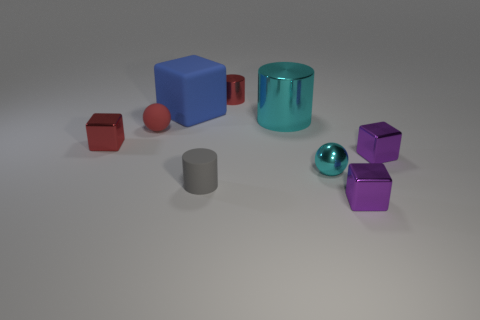What is the material of the ball that is the same color as the small shiny cylinder?
Offer a very short reply. Rubber. How many large metal objects have the same shape as the small gray matte thing?
Offer a very short reply. 1. Does the large blue thing have the same material as the small sphere that is left of the big cube?
Keep it short and to the point. Yes. What is the material of the red block that is the same size as the rubber sphere?
Keep it short and to the point. Metal. Is there a red metallic object of the same size as the gray object?
Provide a short and direct response. Yes. There is a gray object that is the same size as the metallic ball; what is its shape?
Offer a terse response. Cylinder. What number of other things are the same color as the big cube?
Your answer should be compact. 0. There is a tiny red object that is behind the red metallic block and on the left side of the gray object; what shape is it?
Provide a succinct answer. Sphere. Are there any tiny things that are right of the tiny sphere that is on the right side of the big thing that is behind the large cyan cylinder?
Your response must be concise. Yes. How many other objects are there of the same material as the blue object?
Offer a very short reply. 2. 